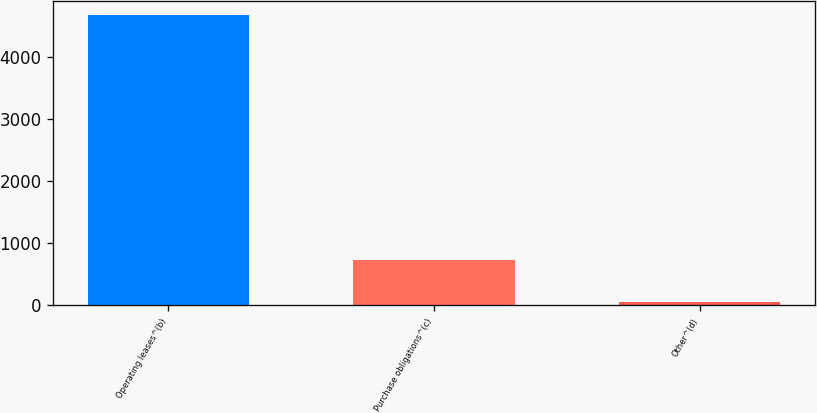Convert chart. <chart><loc_0><loc_0><loc_500><loc_500><bar_chart><fcel>Operating leases^(b)<fcel>Purchase obligations^(c)<fcel>Other^(d)<nl><fcel>4675<fcel>737<fcel>50<nl></chart> 